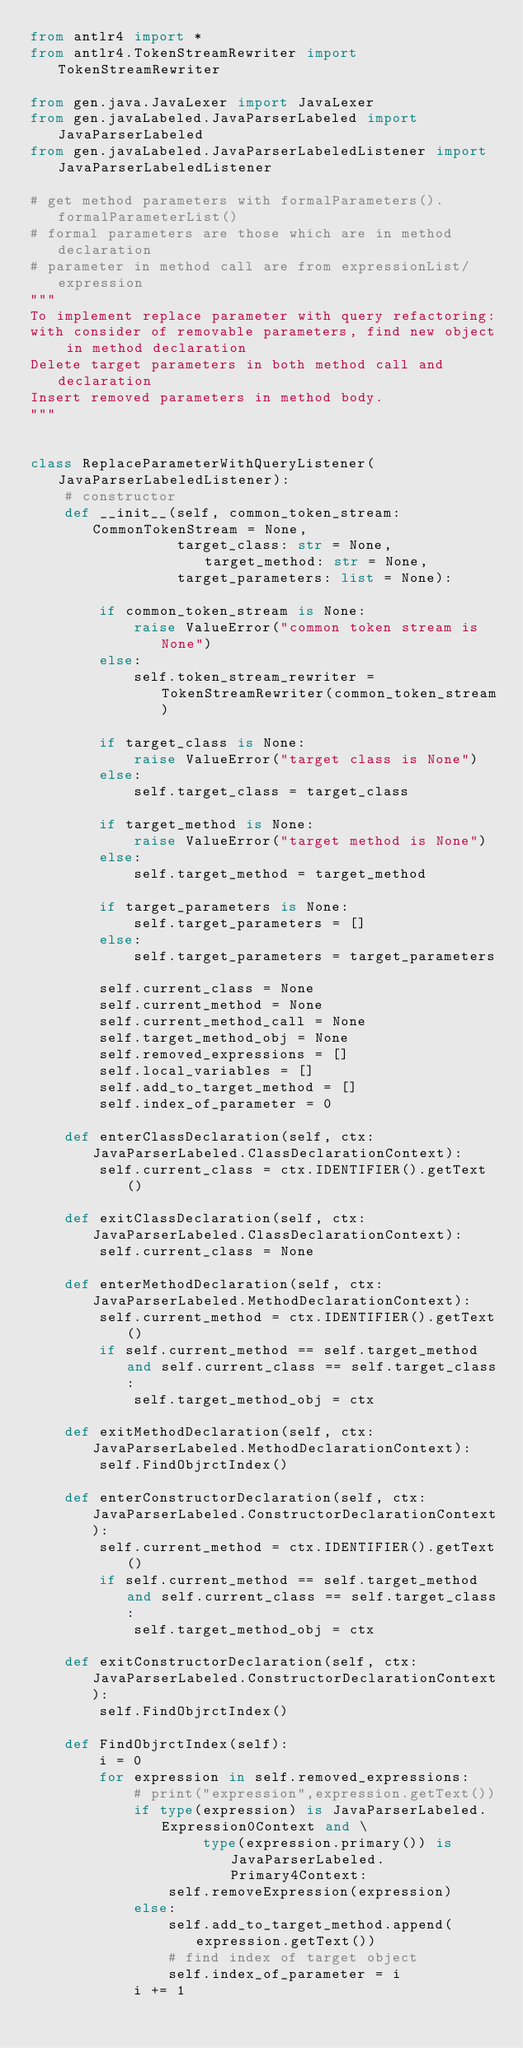<code> <loc_0><loc_0><loc_500><loc_500><_Python_>from antlr4 import *
from antlr4.TokenStreamRewriter import TokenStreamRewriter

from gen.java.JavaLexer import JavaLexer
from gen.javaLabeled.JavaParserLabeled import JavaParserLabeled
from gen.javaLabeled.JavaParserLabeledListener import JavaParserLabeledListener

# get method parameters with formalParameters().formalParameterList()
# formal parameters are those which are in method declaration
# parameter in method call are from expressionList/expression
"""
To implement replace parameter with query refactoring:
with consider of removable parameters, find new object in method declaration
Delete target parameters in both method call and declaration
Insert removed parameters in method body.
"""


class ReplaceParameterWithQueryListener(JavaParserLabeledListener):
    # constructor
    def __init__(self, common_token_stream: CommonTokenStream = None,
                 target_class: str = None, target_method: str = None,
                 target_parameters: list = None):

        if common_token_stream is None:
            raise ValueError("common token stream is None")
        else:
            self.token_stream_rewriter = TokenStreamRewriter(common_token_stream)

        if target_class is None:
            raise ValueError("target class is None")
        else:
            self.target_class = target_class

        if target_method is None:
            raise ValueError("target method is None")
        else:
            self.target_method = target_method

        if target_parameters is None:
            self.target_parameters = []
        else:
            self.target_parameters = target_parameters

        self.current_class = None
        self.current_method = None
        self.current_method_call = None
        self.target_method_obj = None
        self.removed_expressions = []
        self.local_variables = []
        self.add_to_target_method = []
        self.index_of_parameter = 0

    def enterClassDeclaration(self, ctx: JavaParserLabeled.ClassDeclarationContext):
        self.current_class = ctx.IDENTIFIER().getText()

    def exitClassDeclaration(self, ctx: JavaParserLabeled.ClassDeclarationContext):
        self.current_class = None

    def enterMethodDeclaration(self, ctx: JavaParserLabeled.MethodDeclarationContext):
        self.current_method = ctx.IDENTIFIER().getText()
        if self.current_method == self.target_method and self.current_class == self.target_class:
            self.target_method_obj = ctx

    def exitMethodDeclaration(self, ctx: JavaParserLabeled.MethodDeclarationContext):
        self.FindObjrctIndex()

    def enterConstructorDeclaration(self, ctx: JavaParserLabeled.ConstructorDeclarationContext):
        self.current_method = ctx.IDENTIFIER().getText()
        if self.current_method == self.target_method and self.current_class == self.target_class:
            self.target_method_obj = ctx

    def exitConstructorDeclaration(self, ctx: JavaParserLabeled.ConstructorDeclarationContext):
        self.FindObjrctIndex()

    def FindObjrctIndex(self):
        i = 0
        for expression in self.removed_expressions:
            # print("expression",expression.getText())
            if type(expression) is JavaParserLabeled.Expression0Context and \
                    type(expression.primary()) is JavaParserLabeled.Primary4Context:
                self.removeExpression(expression)
            else:
                self.add_to_target_method.append(expression.getText())
                # find index of target object
                self.index_of_parameter = i
            i += 1</code> 